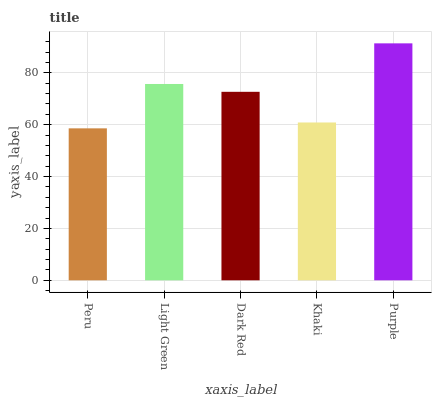Is Peru the minimum?
Answer yes or no. Yes. Is Purple the maximum?
Answer yes or no. Yes. Is Light Green the minimum?
Answer yes or no. No. Is Light Green the maximum?
Answer yes or no. No. Is Light Green greater than Peru?
Answer yes or no. Yes. Is Peru less than Light Green?
Answer yes or no. Yes. Is Peru greater than Light Green?
Answer yes or no. No. Is Light Green less than Peru?
Answer yes or no. No. Is Dark Red the high median?
Answer yes or no. Yes. Is Dark Red the low median?
Answer yes or no. Yes. Is Light Green the high median?
Answer yes or no. No. Is Purple the low median?
Answer yes or no. No. 